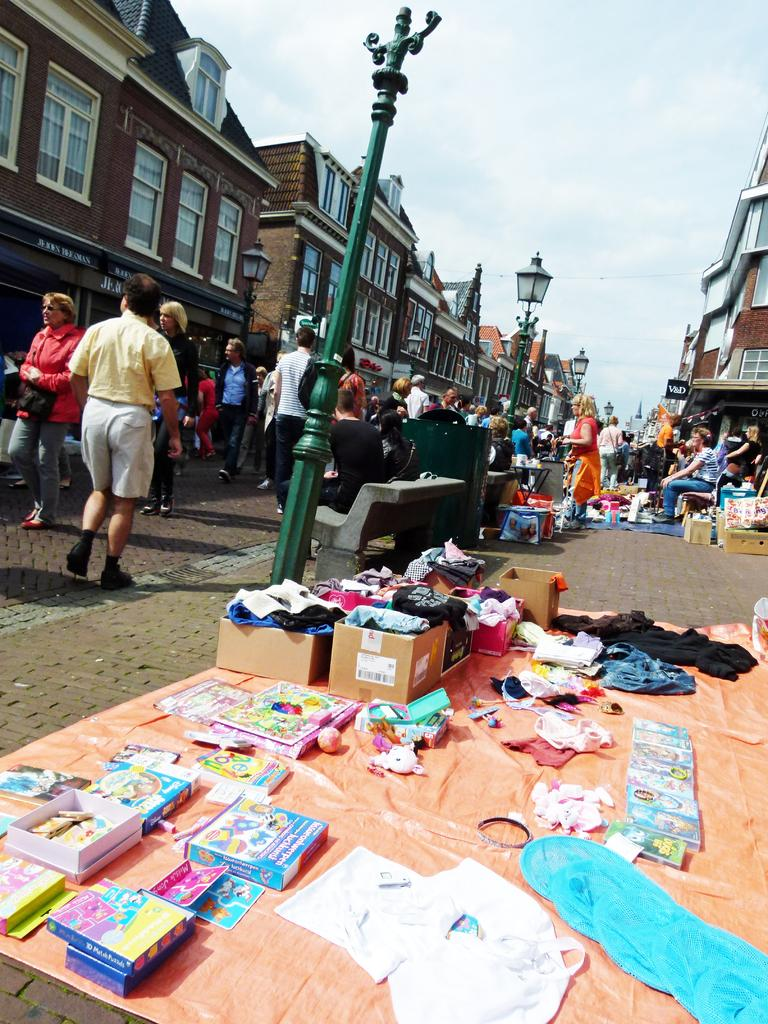What items can be seen on the floor in the image? There are books, cartons, and other objects on the floor in the image. What structures are present in the image? There are poles, benches, and buildings in the image. Are there any people in the image? Yes, there are people present in the image. What type of drug can be seen in the hands of the people in the image? There is no drug present in the image; it only shows people, poles, benches, buildings, books, cartons, and other objects on the floor. How many ducks are visible in the image? There are no ducks present in the image. 